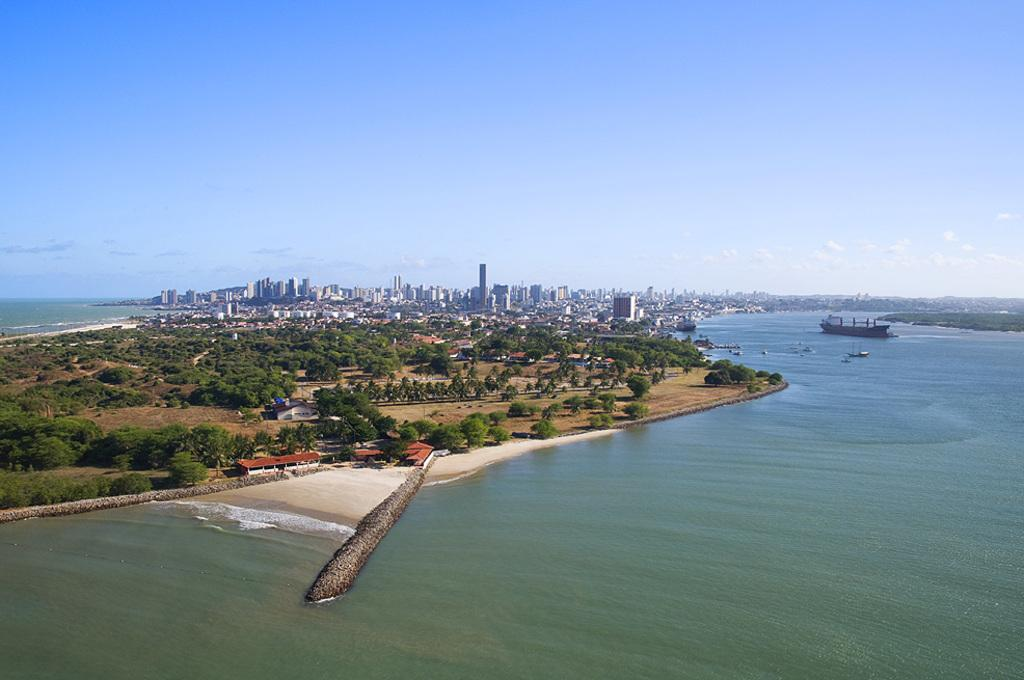What is the primary element in the image? There is water in the image. What is on the water in the image? There are ships on the water. What type of vegetation can be seen in the image? There are trees in the image. What is visible beyond the water in the image? There is land visible in the image. What structures can be seen in the background of the image? There are buildings in the background of the image. How does the volcano erupt in the image? There is no volcano present in the image. What advice does the dad give to the children in the image? There is no dad or children present in the image. 